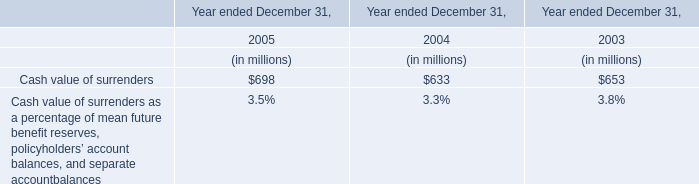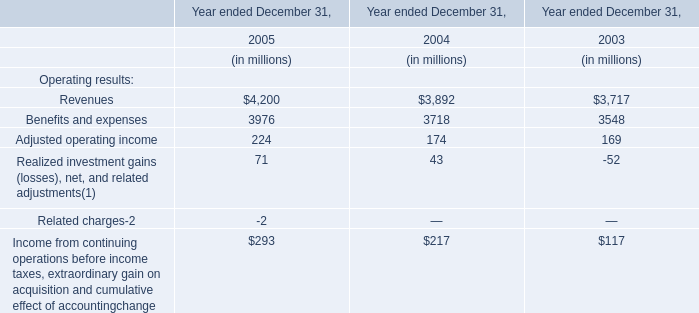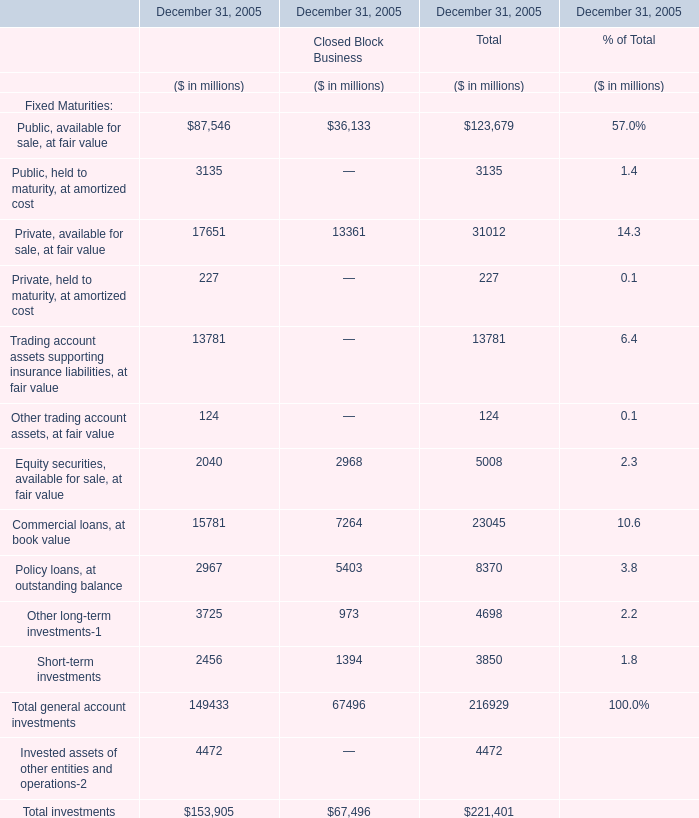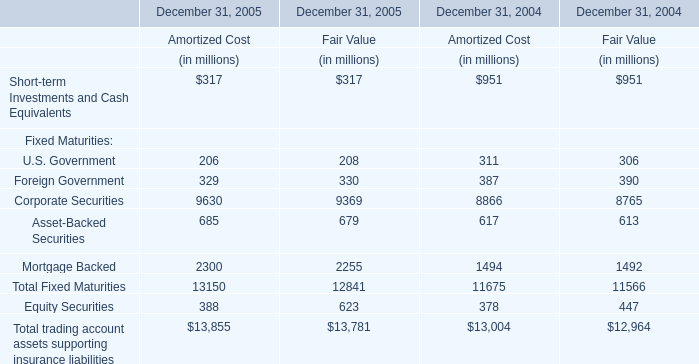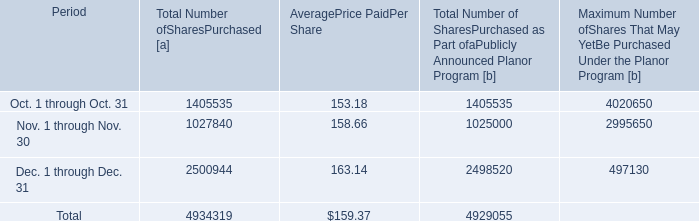How many Closed Block Business exceed the average of Closed Block Business in 2005 for December 31, 2005? 
Answer: 3. 